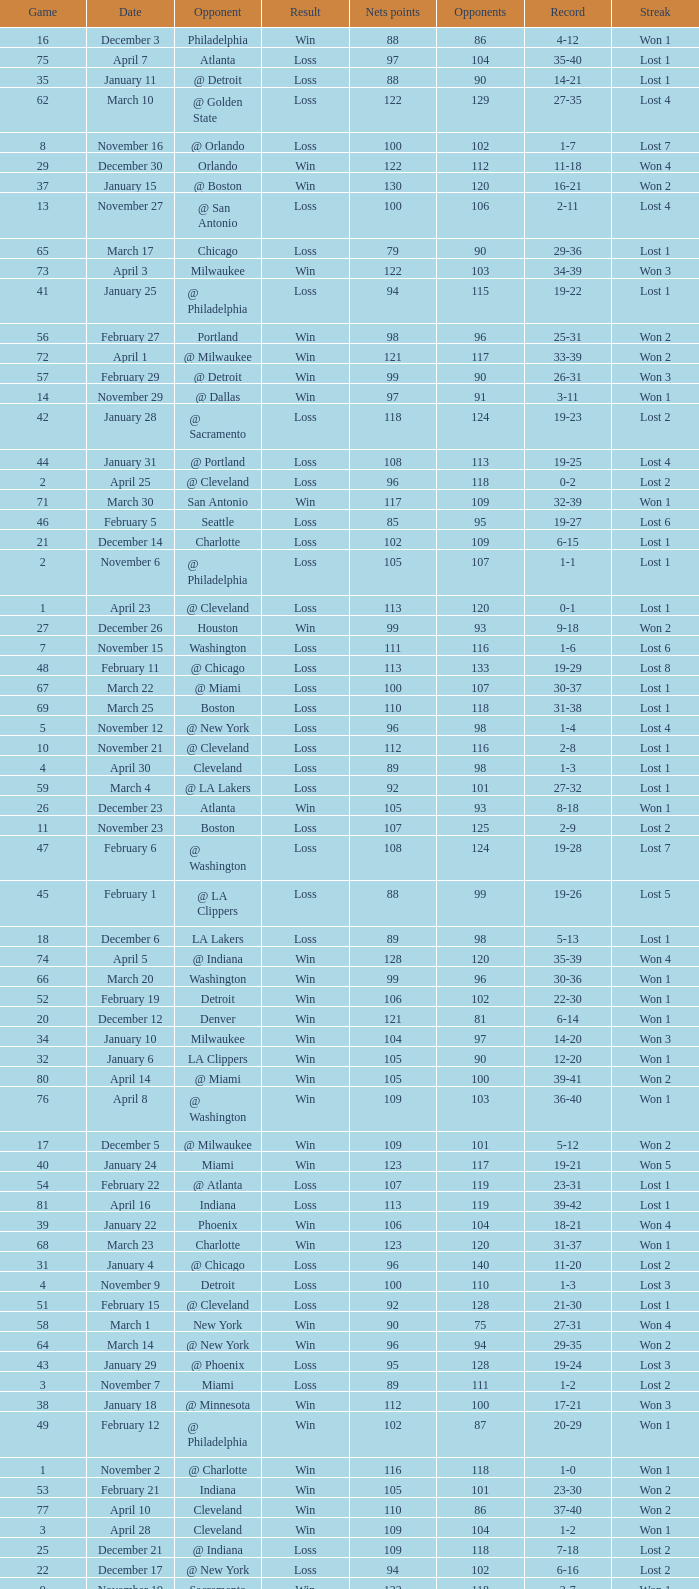Which opponent is from february 12? @ Philadelphia. Could you help me parse every detail presented in this table? {'header': ['Game', 'Date', 'Opponent', 'Result', 'Nets points', 'Opponents', 'Record', 'Streak'], 'rows': [['16', 'December 3', 'Philadelphia', 'Win', '88', '86', '4-12', 'Won 1'], ['75', 'April 7', 'Atlanta', 'Loss', '97', '104', '35-40', 'Lost 1'], ['35', 'January 11', '@ Detroit', 'Loss', '88', '90', '14-21', 'Lost 1'], ['62', 'March 10', '@ Golden State', 'Loss', '122', '129', '27-35', 'Lost 4'], ['8', 'November 16', '@ Orlando', 'Loss', '100', '102', '1-7', 'Lost 7'], ['29', 'December 30', 'Orlando', 'Win', '122', '112', '11-18', 'Won 4'], ['37', 'January 15', '@ Boston', 'Win', '130', '120', '16-21', 'Won 2'], ['13', 'November 27', '@ San Antonio', 'Loss', '100', '106', '2-11', 'Lost 4'], ['65', 'March 17', 'Chicago', 'Loss', '79', '90', '29-36', 'Lost 1'], ['73', 'April 3', 'Milwaukee', 'Win', '122', '103', '34-39', 'Won 3'], ['41', 'January 25', '@ Philadelphia', 'Loss', '94', '115', '19-22', 'Lost 1'], ['56', 'February 27', 'Portland', 'Win', '98', '96', '25-31', 'Won 2'], ['72', 'April 1', '@ Milwaukee', 'Win', '121', '117', '33-39', 'Won 2'], ['57', 'February 29', '@ Detroit', 'Win', '99', '90', '26-31', 'Won 3'], ['14', 'November 29', '@ Dallas', 'Win', '97', '91', '3-11', 'Won 1'], ['42', 'January 28', '@ Sacramento', 'Loss', '118', '124', '19-23', 'Lost 2'], ['44', 'January 31', '@ Portland', 'Loss', '108', '113', '19-25', 'Lost 4'], ['2', 'April 25', '@ Cleveland', 'Loss', '96', '118', '0-2', 'Lost 2'], ['71', 'March 30', 'San Antonio', 'Win', '117', '109', '32-39', 'Won 1'], ['46', 'February 5', 'Seattle', 'Loss', '85', '95', '19-27', 'Lost 6'], ['21', 'December 14', 'Charlotte', 'Loss', '102', '109', '6-15', 'Lost 1'], ['2', 'November 6', '@ Philadelphia', 'Loss', '105', '107', '1-1', 'Lost 1'], ['1', 'April 23', '@ Cleveland', 'Loss', '113', '120', '0-1', 'Lost 1'], ['27', 'December 26', 'Houston', 'Win', '99', '93', '9-18', 'Won 2'], ['7', 'November 15', 'Washington', 'Loss', '111', '116', '1-6', 'Lost 6'], ['48', 'February 11', '@ Chicago', 'Loss', '113', '133', '19-29', 'Lost 8'], ['67', 'March 22', '@ Miami', 'Loss', '100', '107', '30-37', 'Lost 1'], ['69', 'March 25', 'Boston', 'Loss', '110', '118', '31-38', 'Lost 1'], ['5', 'November 12', '@ New York', 'Loss', '96', '98', '1-4', 'Lost 4'], ['10', 'November 21', '@ Cleveland', 'Loss', '112', '116', '2-8', 'Lost 1'], ['4', 'April 30', 'Cleveland', 'Loss', '89', '98', '1-3', 'Lost 1'], ['59', 'March 4', '@ LA Lakers', 'Loss', '92', '101', '27-32', 'Lost 1'], ['26', 'December 23', 'Atlanta', 'Win', '105', '93', '8-18', 'Won 1'], ['11', 'November 23', 'Boston', 'Loss', '107', '125', '2-9', 'Lost 2'], ['47', 'February 6', '@ Washington', 'Loss', '108', '124', '19-28', 'Lost 7'], ['45', 'February 1', '@ LA Clippers', 'Loss', '88', '99', '19-26', 'Lost 5'], ['18', 'December 6', 'LA Lakers', 'Loss', '89', '98', '5-13', 'Lost 1'], ['74', 'April 5', '@ Indiana', 'Win', '128', '120', '35-39', 'Won 4'], ['66', 'March 20', 'Washington', 'Win', '99', '96', '30-36', 'Won 1'], ['52', 'February 19', 'Detroit', 'Win', '106', '102', '22-30', 'Won 1'], ['20', 'December 12', 'Denver', 'Win', '121', '81', '6-14', 'Won 1'], ['34', 'January 10', 'Milwaukee', 'Win', '104', '97', '14-20', 'Won 3'], ['32', 'January 6', 'LA Clippers', 'Win', '105', '90', '12-20', 'Won 1'], ['80', 'April 14', '@ Miami', 'Win', '105', '100', '39-41', 'Won 2'], ['76', 'April 8', '@ Washington', 'Win', '109', '103', '36-40', 'Won 1'], ['17', 'December 5', '@ Milwaukee', 'Win', '109', '101', '5-12', 'Won 2'], ['40', 'January 24', 'Miami', 'Win', '123', '117', '19-21', 'Won 5'], ['54', 'February 22', '@ Atlanta', 'Loss', '107', '119', '23-31', 'Lost 1'], ['81', 'April 16', 'Indiana', 'Loss', '113', '119', '39-42', 'Lost 1'], ['39', 'January 22', 'Phoenix', 'Win', '106', '104', '18-21', 'Won 4'], ['68', 'March 23', 'Charlotte', 'Win', '123', '120', '31-37', 'Won 1'], ['31', 'January 4', '@ Chicago', 'Loss', '96', '140', '11-20', 'Lost 2'], ['4', 'November 9', 'Detroit', 'Loss', '100', '110', '1-3', 'Lost 3'], ['51', 'February 15', '@ Cleveland', 'Loss', '92', '128', '21-30', 'Lost 1'], ['58', 'March 1', 'New York', 'Win', '90', '75', '27-31', 'Won 4'], ['64', 'March 14', '@ New York', 'Win', '96', '94', '29-35', 'Won 2'], ['43', 'January 29', '@ Phoenix', 'Loss', '95', '128', '19-24', 'Lost 3'], ['3', 'November 7', 'Miami', 'Loss', '89', '111', '1-2', 'Lost 2'], ['38', 'January 18', '@ Minnesota', 'Win', '112', '100', '17-21', 'Won 3'], ['49', 'February 12', '@ Philadelphia', 'Win', '102', '87', '20-29', 'Won 1'], ['1', 'November 2', '@ Charlotte', 'Win', '116', '118', '1-0', 'Won 1'], ['53', 'February 21', 'Indiana', 'Win', '105', '101', '23-30', 'Won 2'], ['77', 'April 10', 'Cleveland', 'Win', '110', '86', '37-40', 'Won 2'], ['3', 'April 28', 'Cleveland', 'Win', '109', '104', '1-2', 'Won 1'], ['25', 'December 21', '@ Indiana', 'Loss', '109', '118', '7-18', 'Lost 2'], ['22', 'December 17', '@ New York', 'Loss', '94', '102', '6-16', 'Lost 2'], ['9', 'November 19', 'Sacramento', 'Win', '122', '118', '2-7', 'Won 1'], ['79', 'April 13', '@ Orlando', 'Win', '110', '104', '38-41', 'Won 1'], ['55', 'February 25', 'Boston', 'Win', '109', '95', '24-31', 'Won 1'], ['61', 'March 7', '@ Seattle', 'Loss', '98', '109', '27-34', 'Lost 3'], ['24', 'December 20', 'Chicago', 'Loss', '98', '115', '7-17', 'Lost 1'], ['15', 'November 30', '@ Denver', 'Loss', '97', '107', '3-12', 'Lost 1'], ['23', 'December 18', 'Cleveland', 'Win', '102', '93', '7-16', 'Won 1'], ['82', 'April 18', 'Orlando', 'Win', '127', '111', '40-42', 'Won 1'], ['63', 'March 13', '@ Boston', 'Win', '110', '108', '28-35', 'Won 1'], ['30', 'January 3', 'Washington', 'Loss', '108', '112', '11-19', 'Lost 1'], ['50', 'February 14', 'Philadelphia', 'Win', '107', '99', '21-29', 'Won 2'], ['36', 'January 14', 'Dallas', 'Win', '97', '88', '15-21', 'Won 1'], ['70', 'March 28', 'Golden State', 'Loss', '148', '153', '31-39', 'Lost 2'], ['33', 'January 8', 'Minnesota', 'Win', '103', '97', '13-20', 'Won 2'], ['19', 'December 10', 'New York', 'Loss', '88', '114', '5-14', 'Lost 2'], ['60', 'March 6', '@ Utah', 'Loss', '96', '117', '27-33', 'Lost 2'], ['78', 'April 11', '@ Atlanta', 'Loss', '98', '118', '37-41', 'Lost 1'], ['28', 'December 27', '@ Charlotte', 'Win', '136', '120', '10-18', 'Won 3'], ['6', 'November 13', 'Utah', 'Loss', '92', '98', '1-5', 'Lost 5'], ['12', 'November 26', '@ Houston', 'Loss', '109', '118', '2-10', 'Lost 3']]} 